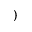<formula> <loc_0><loc_0><loc_500><loc_500>)</formula> 